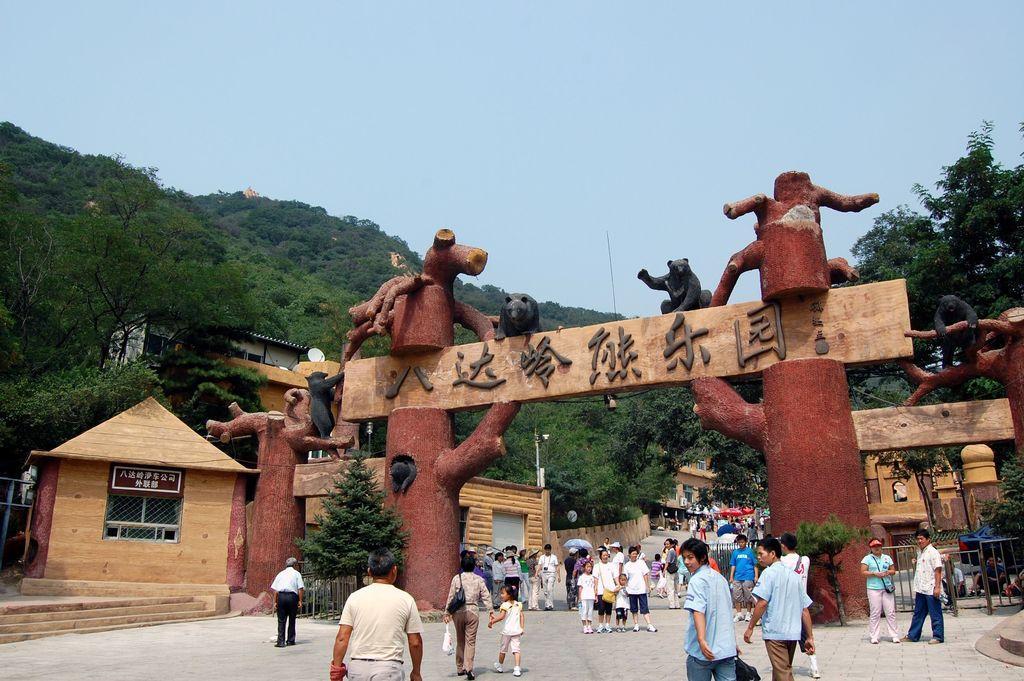In one or two sentences, can you explain what this image depicts? In this picture we can see group of people, few are standing and few are walking, in the background we can see an arch, few houses and trees. 